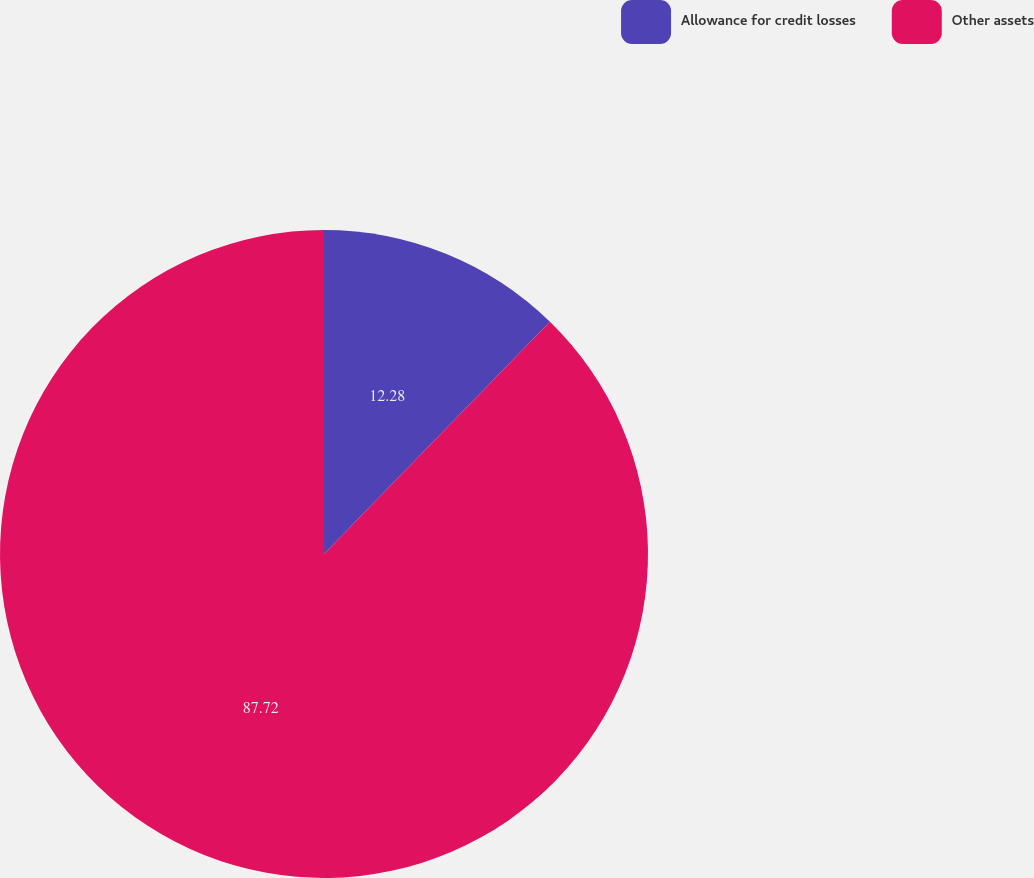<chart> <loc_0><loc_0><loc_500><loc_500><pie_chart><fcel>Allowance for credit losses<fcel>Other assets<nl><fcel>12.28%<fcel>87.72%<nl></chart> 